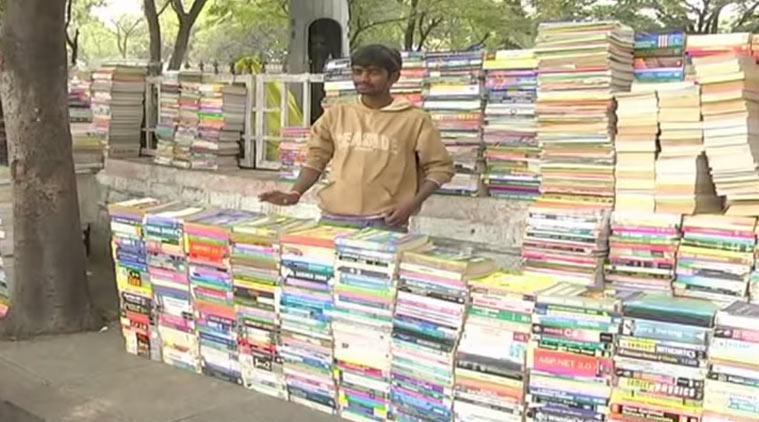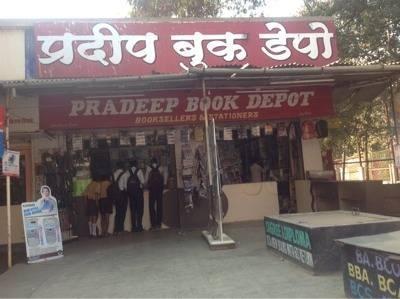The first image is the image on the left, the second image is the image on the right. Assess this claim about the two images: "The image to the left appears to feature an open air shop; no windows seem to bar the store from the elements.". Correct or not? Answer yes or no. Yes. The first image is the image on the left, the second image is the image on the right. For the images displayed, is the sentence "In one of the images a person is standing by books with no outside signage." factually correct? Answer yes or no. Yes. 